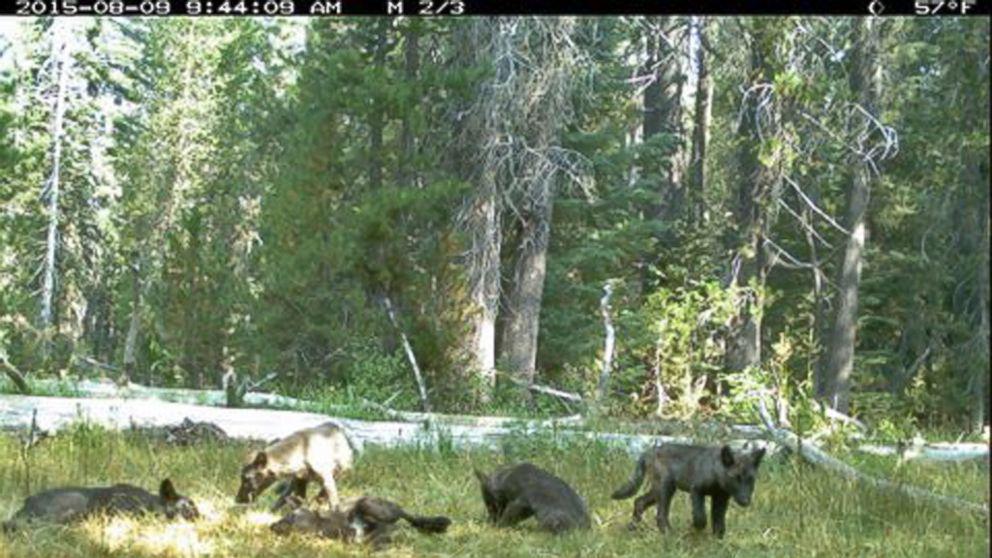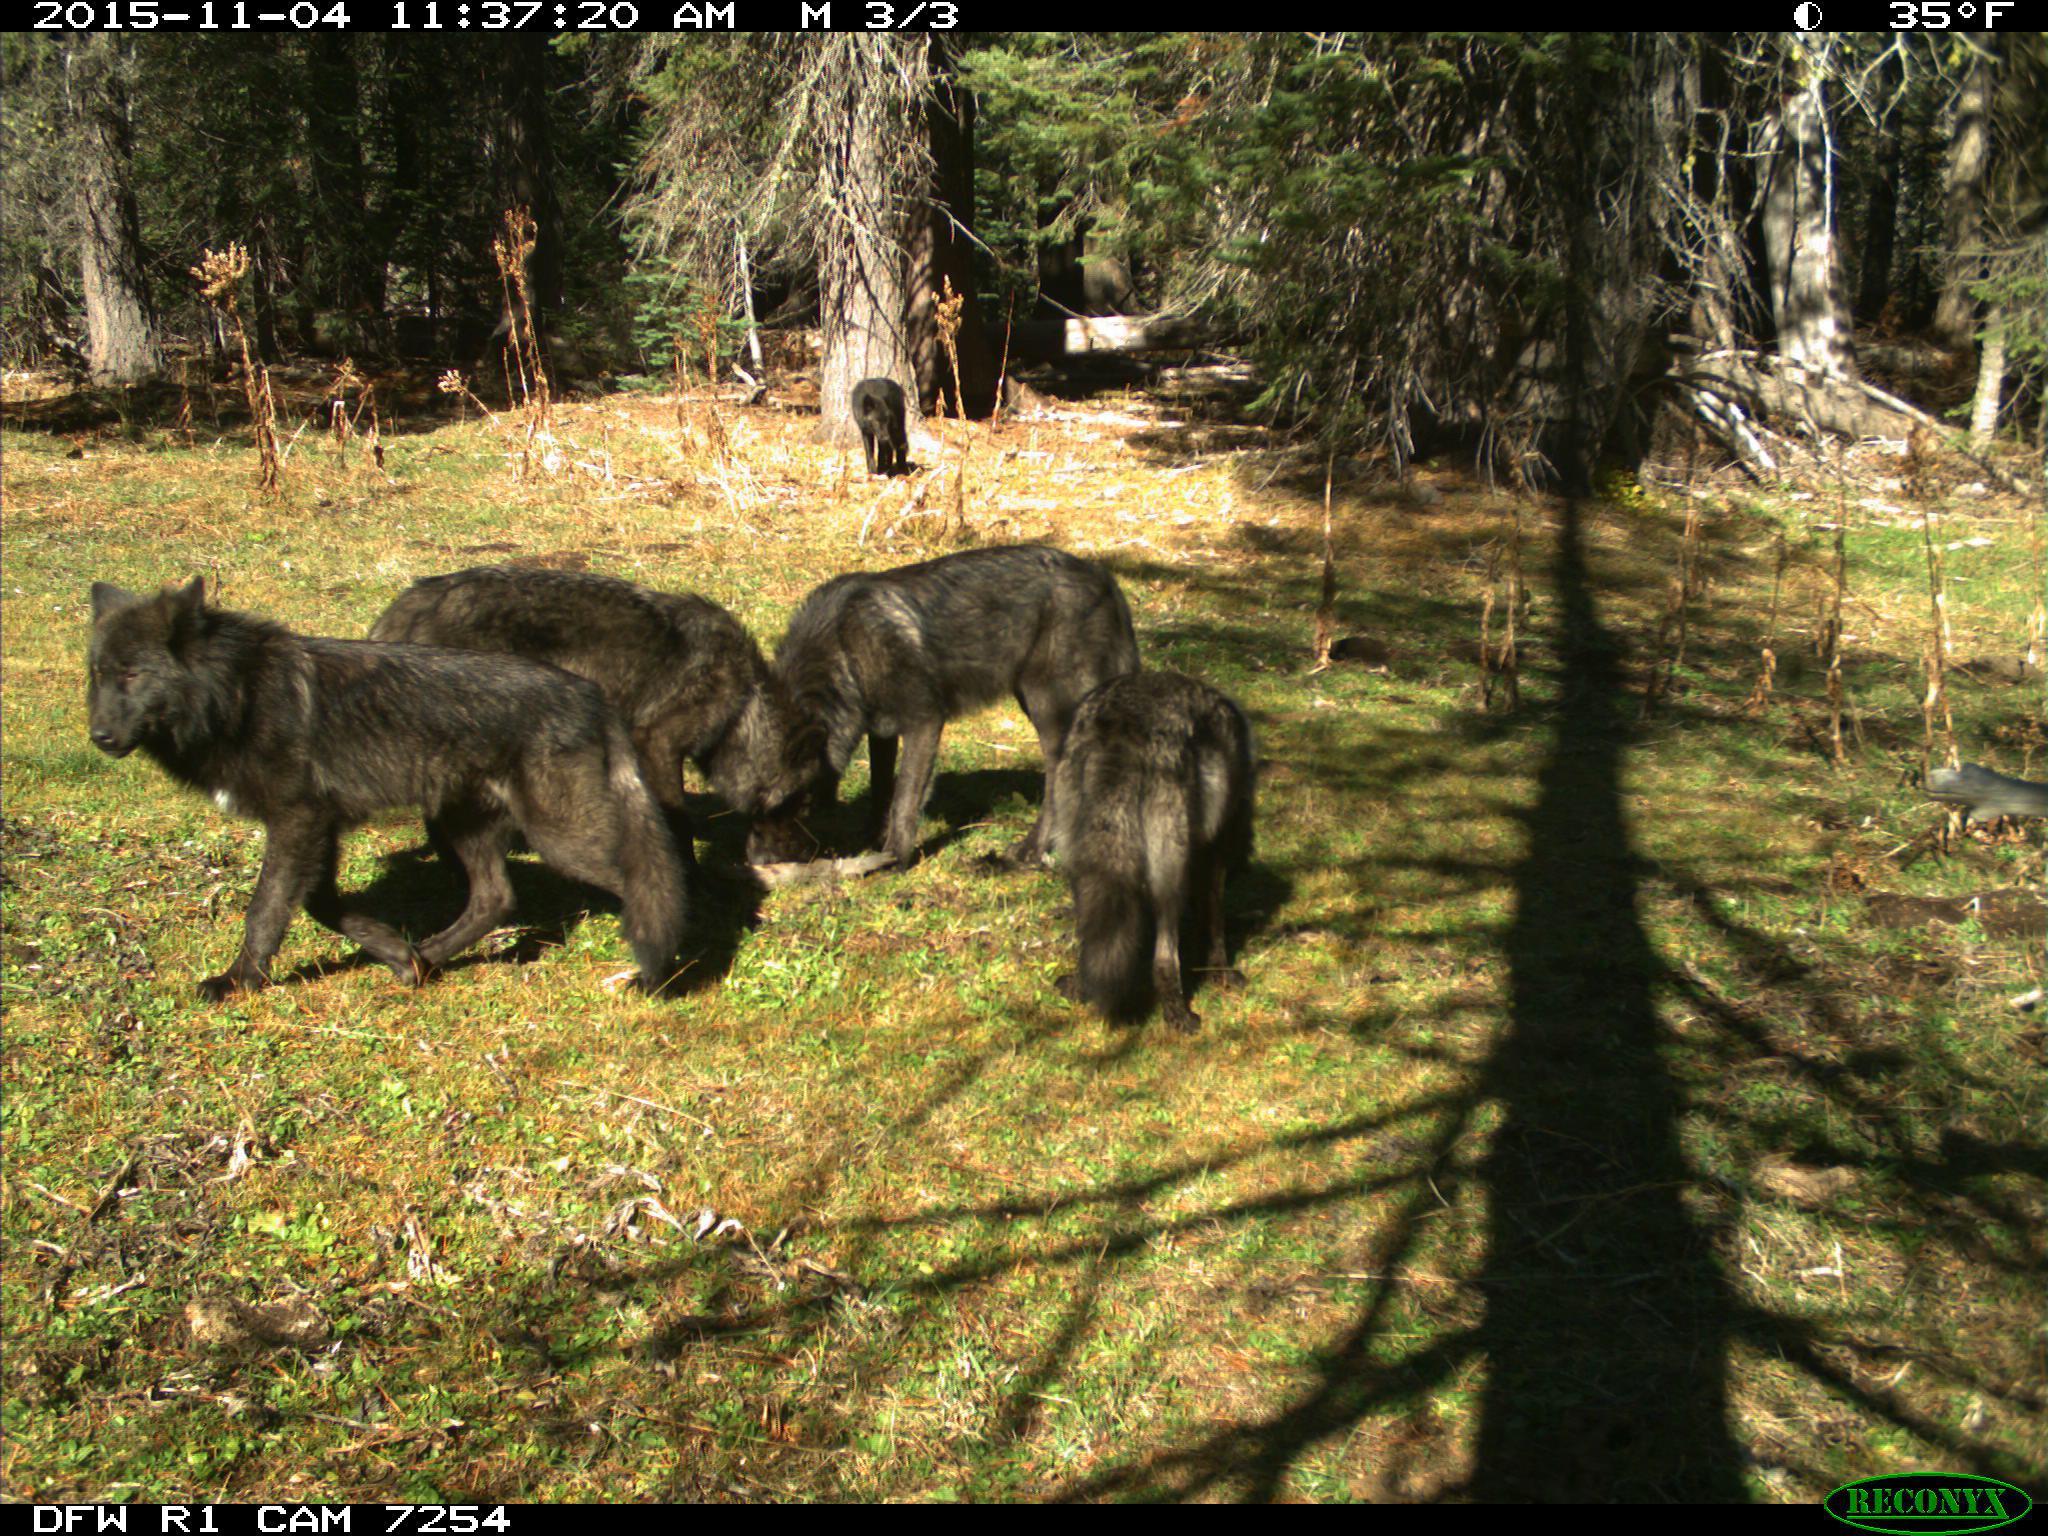The first image is the image on the left, the second image is the image on the right. For the images shown, is this caption "At least three animals are lying down in the grass in the image on the left." true? Answer yes or no. Yes. 